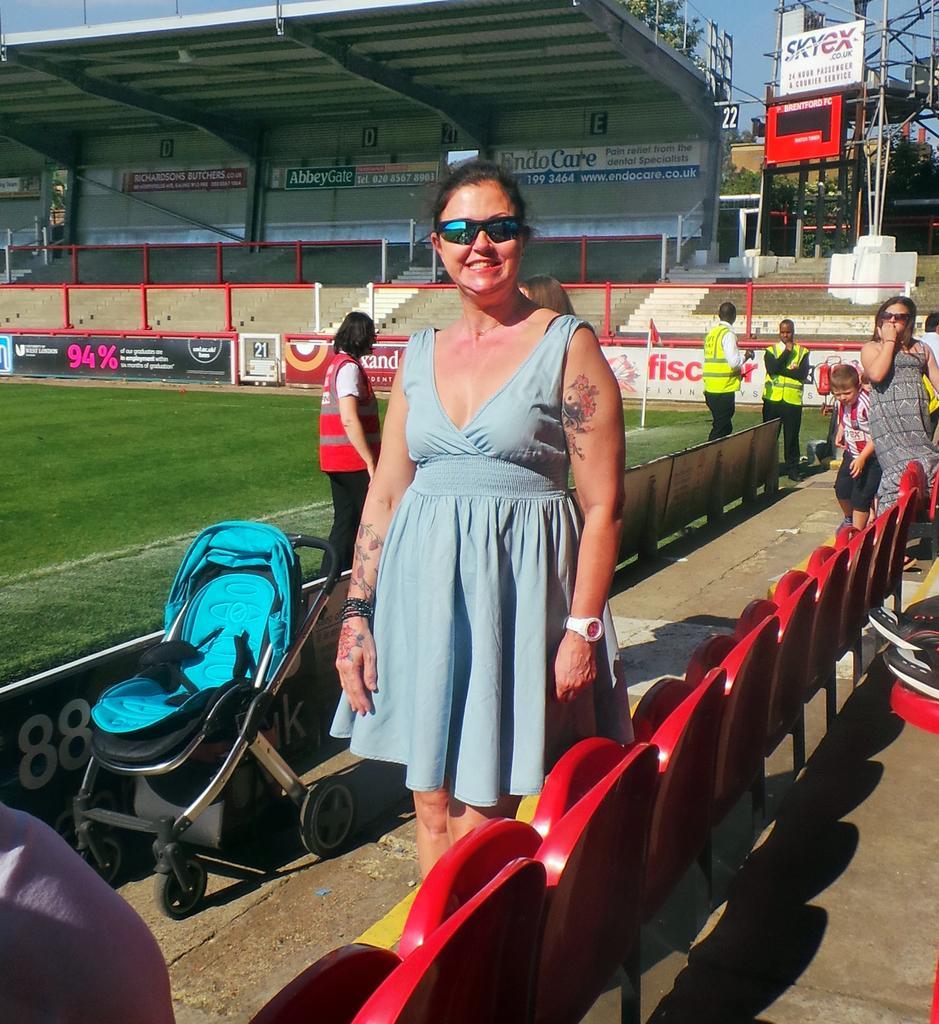Can you describe this image briefly? In this image, in the middle, we can see a woman standing, there are some chairs. On the right side, we can see some people standing. On the left side, we can see a baby trolley and there's grass on the ground. 